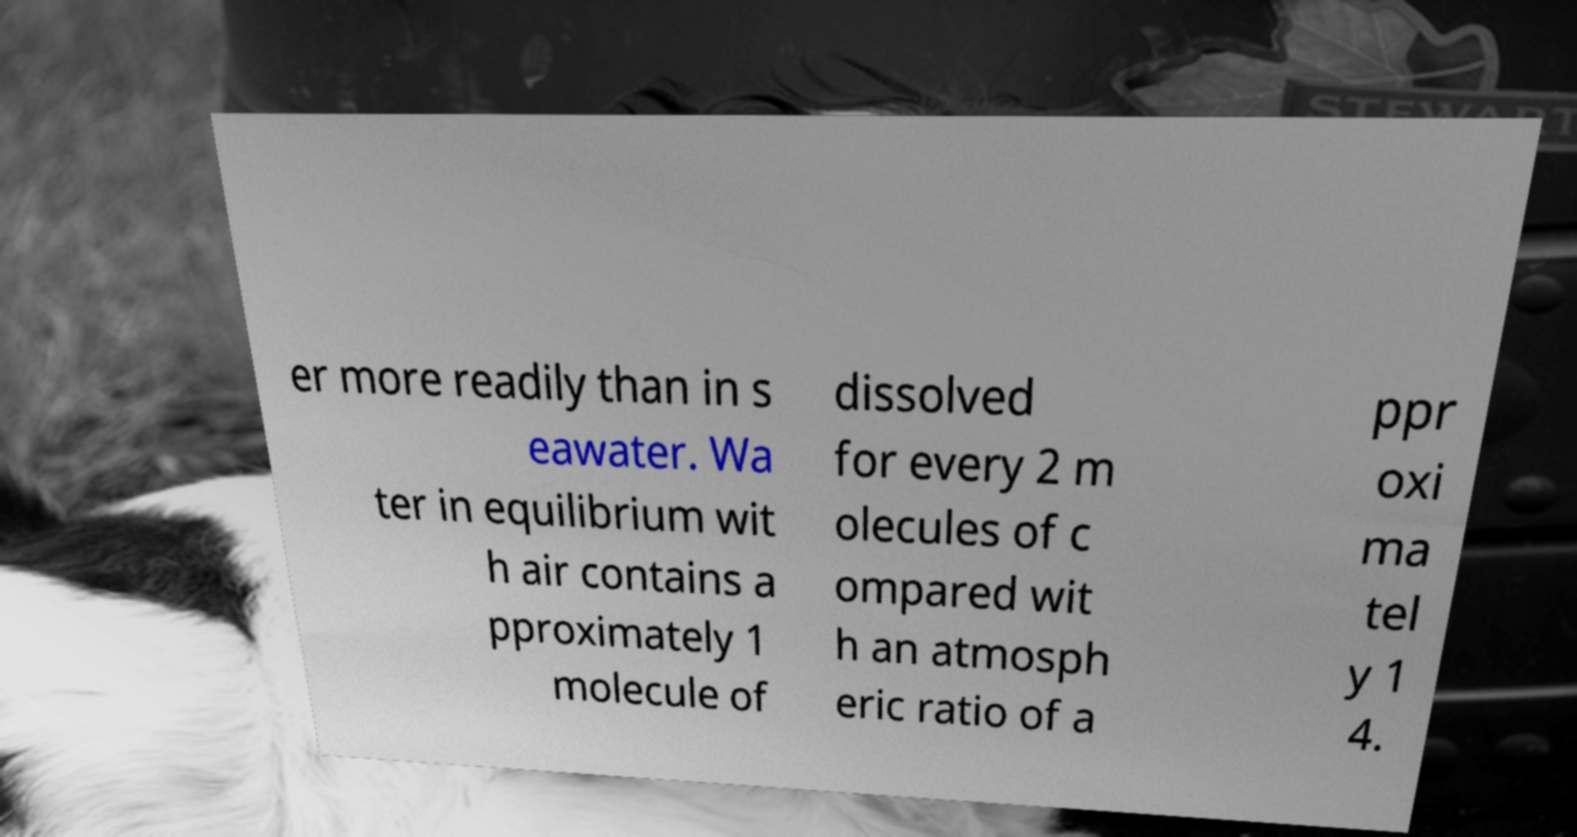Can you accurately transcribe the text from the provided image for me? er more readily than in s eawater. Wa ter in equilibrium wit h air contains a pproximately 1 molecule of dissolved for every 2 m olecules of c ompared wit h an atmosph eric ratio of a ppr oxi ma tel y 1 4. 